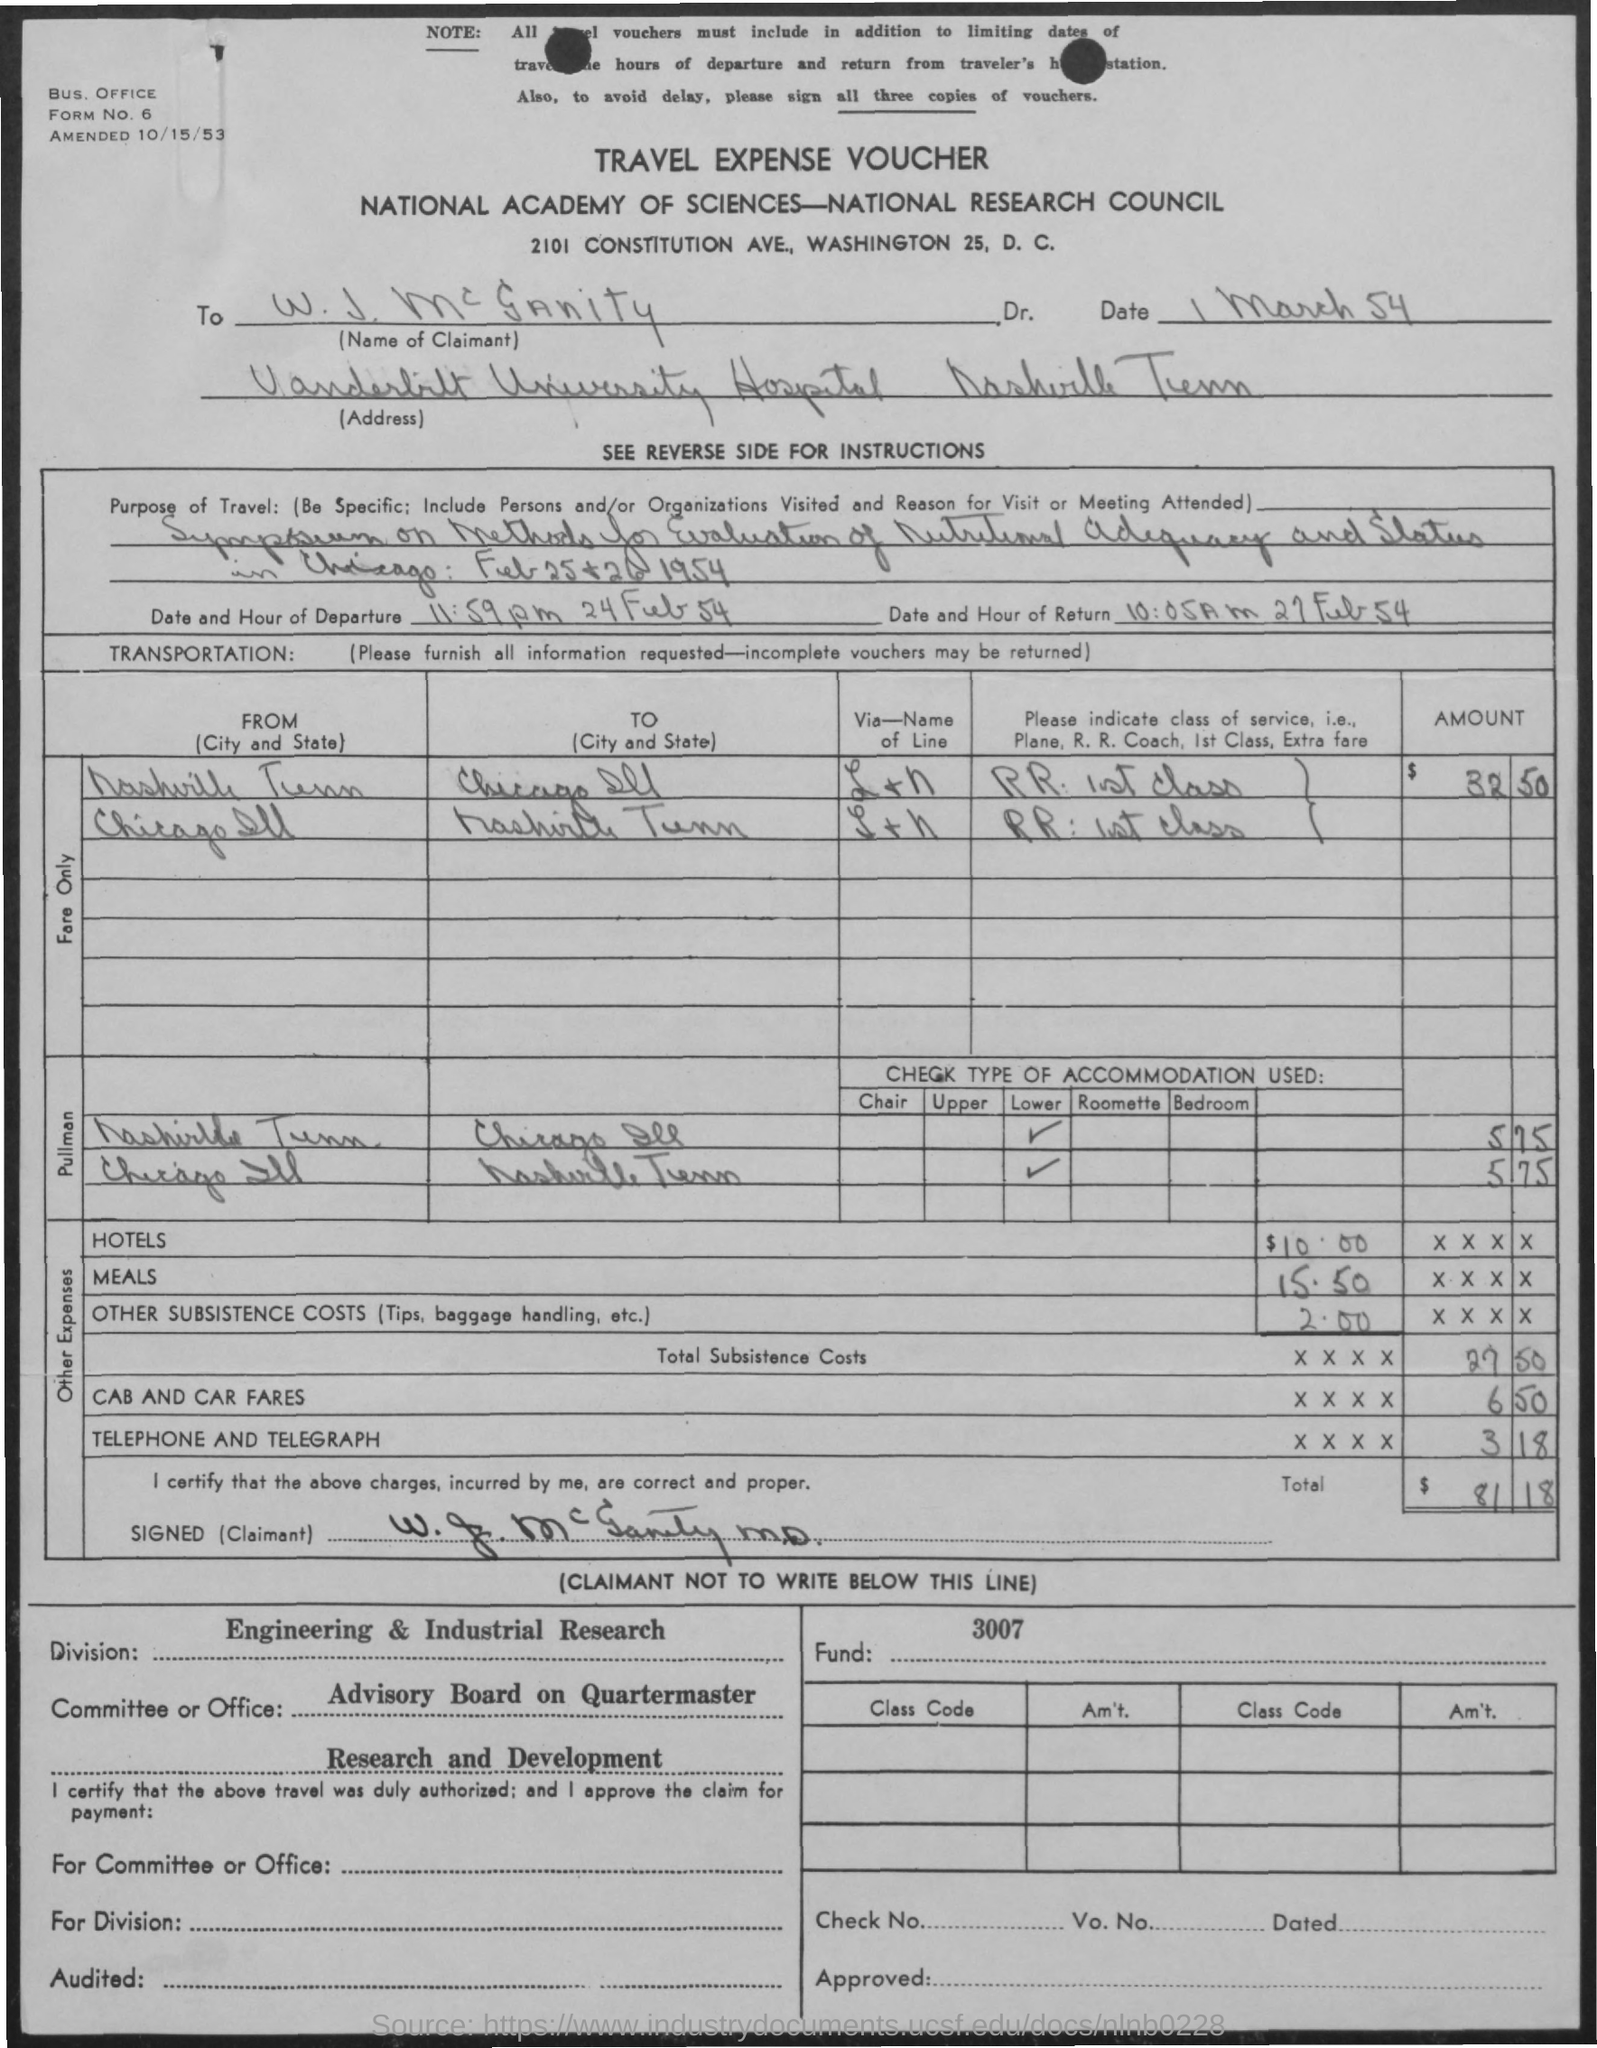what is the date of amendment ? The document was amended on October 15, 1953, as stated in the note at the top of the travel expense voucher. 